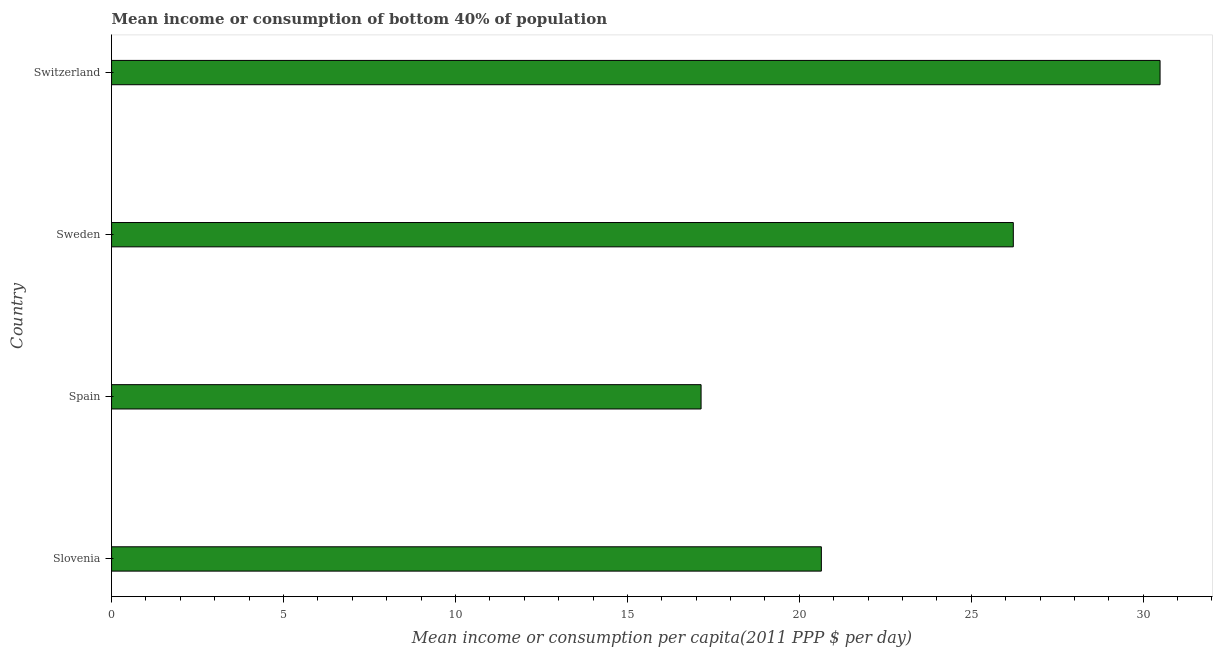Does the graph contain any zero values?
Offer a terse response. No. Does the graph contain grids?
Offer a very short reply. No. What is the title of the graph?
Your answer should be compact. Mean income or consumption of bottom 40% of population. What is the label or title of the X-axis?
Give a very brief answer. Mean income or consumption per capita(2011 PPP $ per day). What is the label or title of the Y-axis?
Make the answer very short. Country. What is the mean income or consumption in Slovenia?
Your response must be concise. 20.64. Across all countries, what is the maximum mean income or consumption?
Provide a succinct answer. 30.49. Across all countries, what is the minimum mean income or consumption?
Provide a succinct answer. 17.14. In which country was the mean income or consumption maximum?
Your answer should be compact. Switzerland. What is the sum of the mean income or consumption?
Give a very brief answer. 94.5. What is the difference between the mean income or consumption in Slovenia and Switzerland?
Ensure brevity in your answer.  -9.85. What is the average mean income or consumption per country?
Provide a succinct answer. 23.62. What is the median mean income or consumption?
Provide a succinct answer. 23.43. What is the ratio of the mean income or consumption in Sweden to that in Switzerland?
Make the answer very short. 0.86. Is the mean income or consumption in Slovenia less than that in Sweden?
Your answer should be very brief. Yes. Is the difference between the mean income or consumption in Spain and Sweden greater than the difference between any two countries?
Your answer should be compact. No. What is the difference between the highest and the second highest mean income or consumption?
Offer a very short reply. 4.27. Is the sum of the mean income or consumption in Slovenia and Switzerland greater than the maximum mean income or consumption across all countries?
Ensure brevity in your answer.  Yes. What is the difference between the highest and the lowest mean income or consumption?
Provide a short and direct response. 13.35. Are all the bars in the graph horizontal?
Your response must be concise. Yes. What is the difference between two consecutive major ticks on the X-axis?
Ensure brevity in your answer.  5. Are the values on the major ticks of X-axis written in scientific E-notation?
Your answer should be very brief. No. What is the Mean income or consumption per capita(2011 PPP $ per day) of Slovenia?
Ensure brevity in your answer.  20.64. What is the Mean income or consumption per capita(2011 PPP $ per day) of Spain?
Your response must be concise. 17.14. What is the Mean income or consumption per capita(2011 PPP $ per day) of Sweden?
Your answer should be very brief. 26.22. What is the Mean income or consumption per capita(2011 PPP $ per day) in Switzerland?
Provide a short and direct response. 30.49. What is the difference between the Mean income or consumption per capita(2011 PPP $ per day) in Slovenia and Spain?
Offer a very short reply. 3.5. What is the difference between the Mean income or consumption per capita(2011 PPP $ per day) in Slovenia and Sweden?
Ensure brevity in your answer.  -5.58. What is the difference between the Mean income or consumption per capita(2011 PPP $ per day) in Slovenia and Switzerland?
Your answer should be very brief. -9.85. What is the difference between the Mean income or consumption per capita(2011 PPP $ per day) in Spain and Sweden?
Your answer should be very brief. -9.08. What is the difference between the Mean income or consumption per capita(2011 PPP $ per day) in Spain and Switzerland?
Ensure brevity in your answer.  -13.35. What is the difference between the Mean income or consumption per capita(2011 PPP $ per day) in Sweden and Switzerland?
Make the answer very short. -4.27. What is the ratio of the Mean income or consumption per capita(2011 PPP $ per day) in Slovenia to that in Spain?
Offer a very short reply. 1.2. What is the ratio of the Mean income or consumption per capita(2011 PPP $ per day) in Slovenia to that in Sweden?
Your answer should be compact. 0.79. What is the ratio of the Mean income or consumption per capita(2011 PPP $ per day) in Slovenia to that in Switzerland?
Provide a succinct answer. 0.68. What is the ratio of the Mean income or consumption per capita(2011 PPP $ per day) in Spain to that in Sweden?
Give a very brief answer. 0.65. What is the ratio of the Mean income or consumption per capita(2011 PPP $ per day) in Spain to that in Switzerland?
Ensure brevity in your answer.  0.56. What is the ratio of the Mean income or consumption per capita(2011 PPP $ per day) in Sweden to that in Switzerland?
Provide a succinct answer. 0.86. 